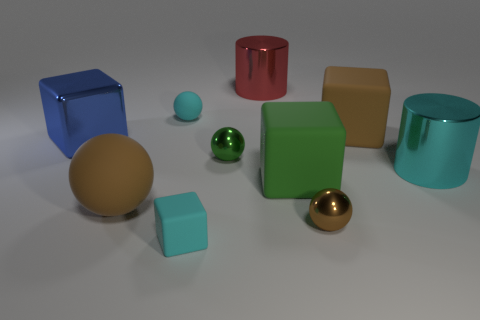What size is the cylinder that is the same material as the big cyan thing?
Make the answer very short. Large. Are there any things that have the same color as the shiny block?
Offer a terse response. No. There is a shiny ball left of the red shiny cylinder; does it have the same color as the large rubber thing that is to the left of the tiny green metal thing?
Your response must be concise. No. There is a shiny object that is the same color as the small block; what is its size?
Offer a terse response. Large. Are there any blue cubes that have the same material as the large blue thing?
Offer a terse response. No. What color is the small matte cube?
Your answer should be compact. Cyan. How big is the cylinder that is in front of the big metallic object on the left side of the small ball to the left of the small matte block?
Provide a succinct answer. Large. What number of other objects are the same shape as the tiny brown metal object?
Ensure brevity in your answer.  3. What color is the small thing that is on the left side of the tiny green shiny thing and in front of the big metallic block?
Your answer should be very brief. Cyan. Is the color of the large shiny object that is behind the blue shiny thing the same as the large ball?
Offer a terse response. No. 